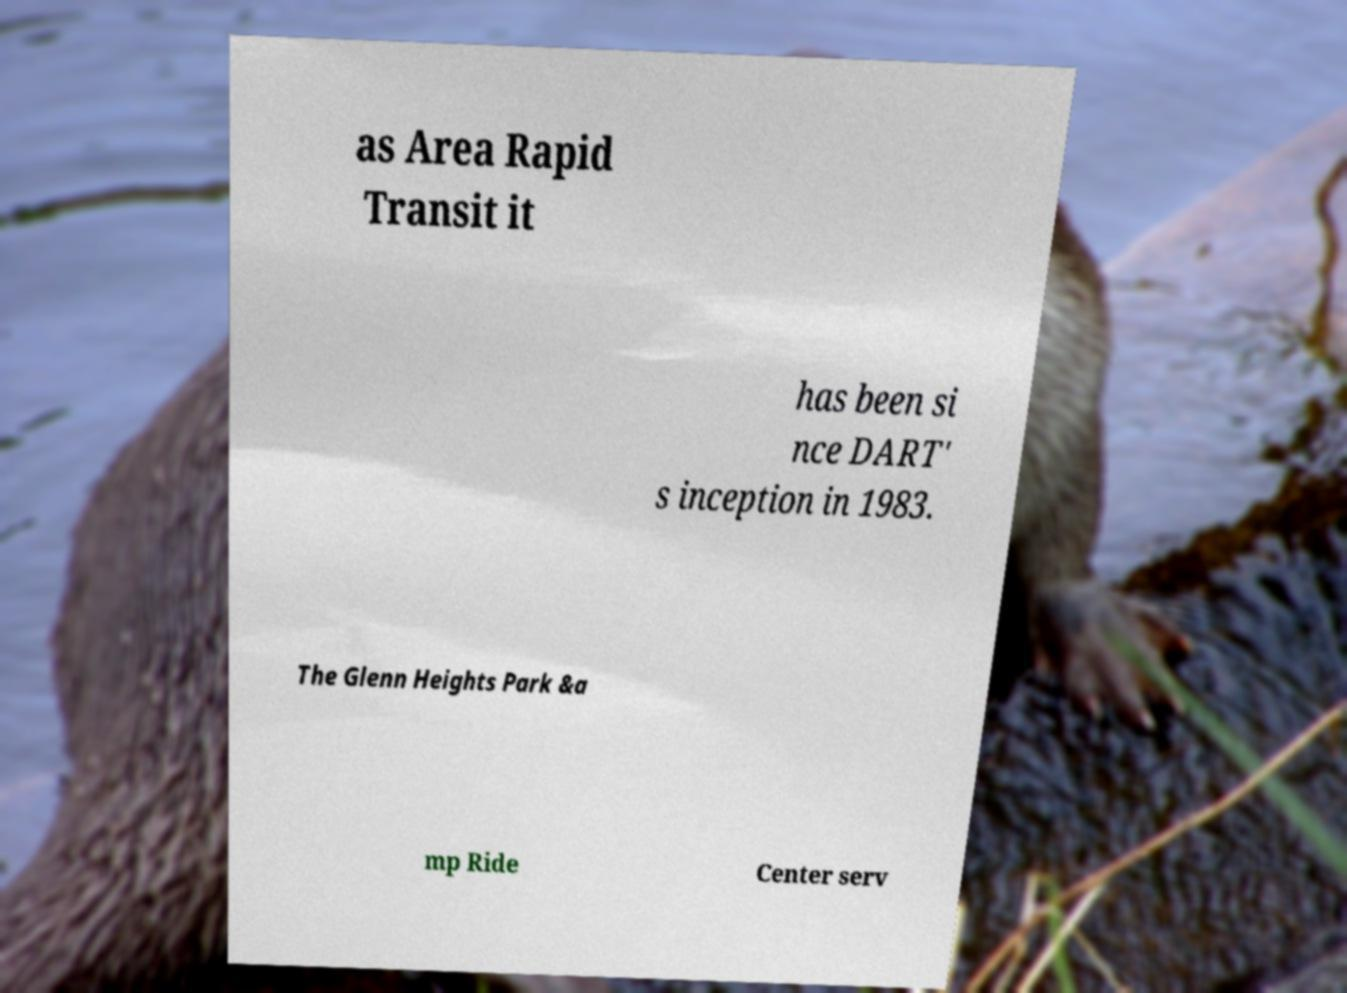Please identify and transcribe the text found in this image. as Area Rapid Transit it has been si nce DART' s inception in 1983. The Glenn Heights Park &a mp Ride Center serv 